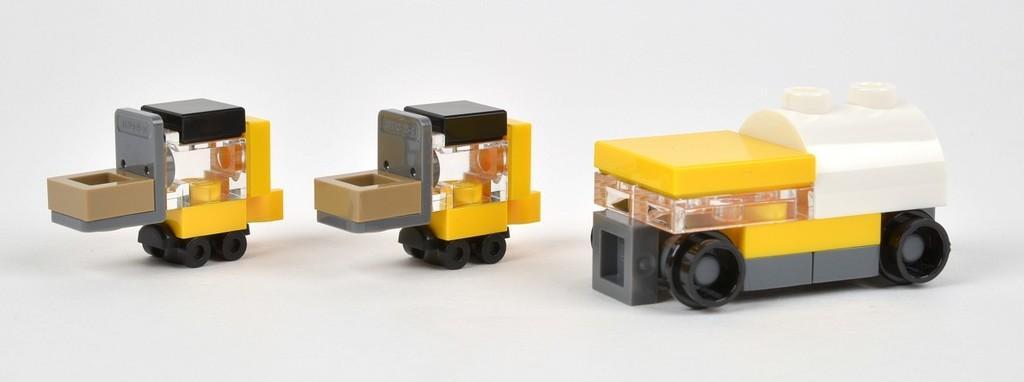Could you give a brief overview of what you see in this image? In this image, we can see toy vehicles placed on the table. 